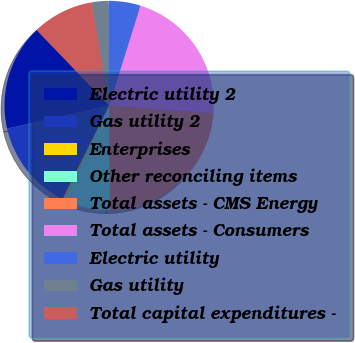Convert chart. <chart><loc_0><loc_0><loc_500><loc_500><pie_chart><fcel>Electric utility 2<fcel>Gas utility 2<fcel>Enterprises<fcel>Other reconciling items<fcel>Total assets - CMS Energy<fcel>Total assets - Consumers<fcel>Electric utility<fcel>Gas utility<fcel>Total capital expenditures -<nl><fcel>16.38%<fcel>14.09%<fcel>0.31%<fcel>7.2%<fcel>23.66%<fcel>21.36%<fcel>4.9%<fcel>2.61%<fcel>9.49%<nl></chart> 